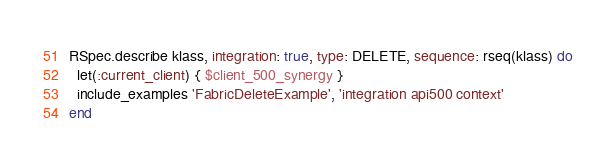Convert code to text. <code><loc_0><loc_0><loc_500><loc_500><_Ruby_>RSpec.describe klass, integration: true, type: DELETE, sequence: rseq(klass) do
  let(:current_client) { $client_500_synergy }
  include_examples 'FabricDeleteExample', 'integration api500 context'
end
</code> 